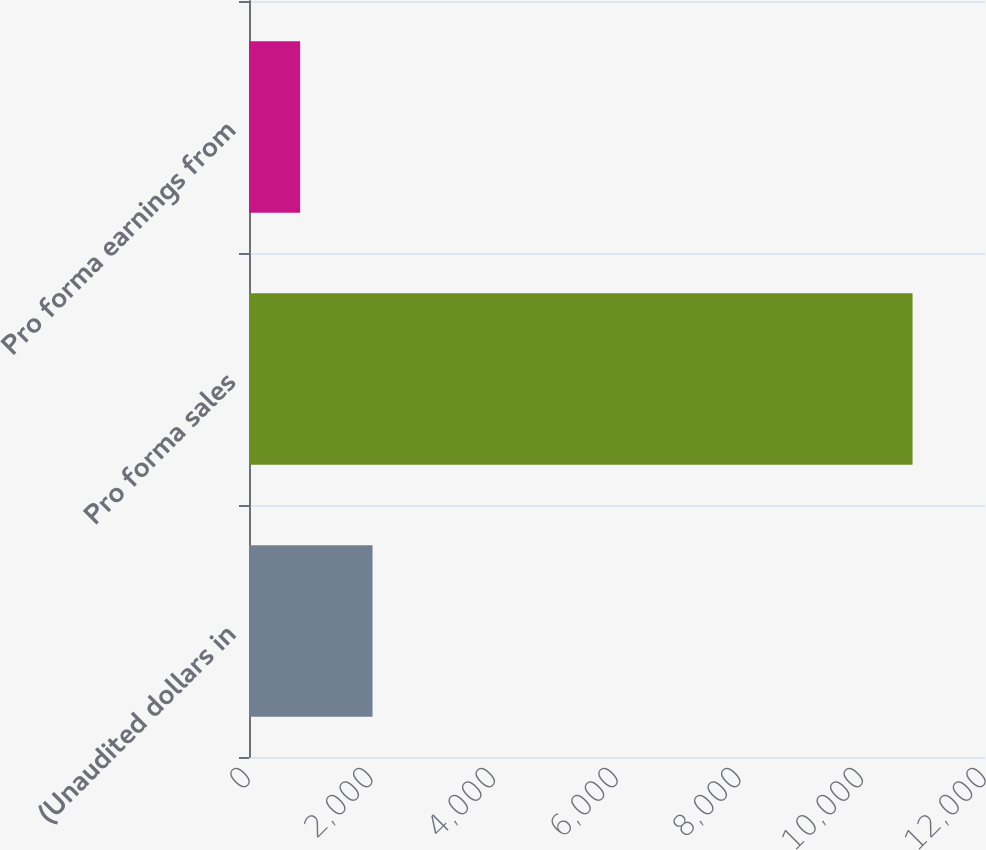<chart> <loc_0><loc_0><loc_500><loc_500><bar_chart><fcel>(Unaudited dollars in<fcel>Pro forma sales<fcel>Pro forma earnings from<nl><fcel>2014<fcel>10819<fcel>834<nl></chart> 